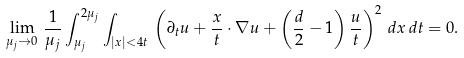Convert formula to latex. <formula><loc_0><loc_0><loc_500><loc_500>\lim _ { \mu _ { j } \to 0 } \, \frac { 1 } { \mu _ { j } } \int _ { \mu _ { j } } ^ { 2 \mu _ { j } } \int _ { | x | < 4 t } \, \left ( \partial _ { t } u + \frac { x } { t } \cdot \nabla u + \left ( \frac { d } { 2 } - 1 \right ) \frac { u } { t } \right ) ^ { 2 } \, d x \, d t = 0 .</formula> 